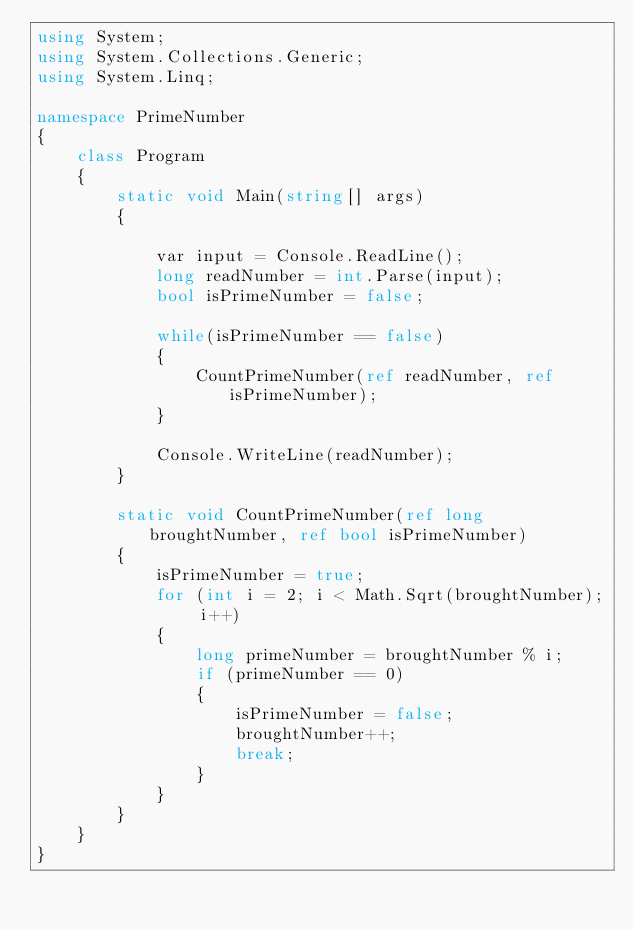<code> <loc_0><loc_0><loc_500><loc_500><_C#_>using System;
using System.Collections.Generic;
using System.Linq;
 
namespace PrimeNumber
{
    class Program
    {
        static void Main(string[] args)
        {
 
            var input = Console.ReadLine();
            long readNumber = int.Parse(input);
            bool isPrimeNumber = false;
            
            while(isPrimeNumber == false)
            {
                CountPrimeNumber(ref readNumber, ref isPrimeNumber);
            }
 
            Console.WriteLine(readNumber);                                 
        }
 
        static void CountPrimeNumber(ref long broughtNumber, ref bool isPrimeNumber)
        {
            isPrimeNumber = true;
            for (int i = 2; i < Math.Sqrt(broughtNumber); i++)
            {
                long primeNumber = broughtNumber % i;
                if (primeNumber == 0)
                {                    
                    isPrimeNumber = false;
                    broughtNumber++;
                    break;
                }                                
            }            
        }
    }
}</code> 